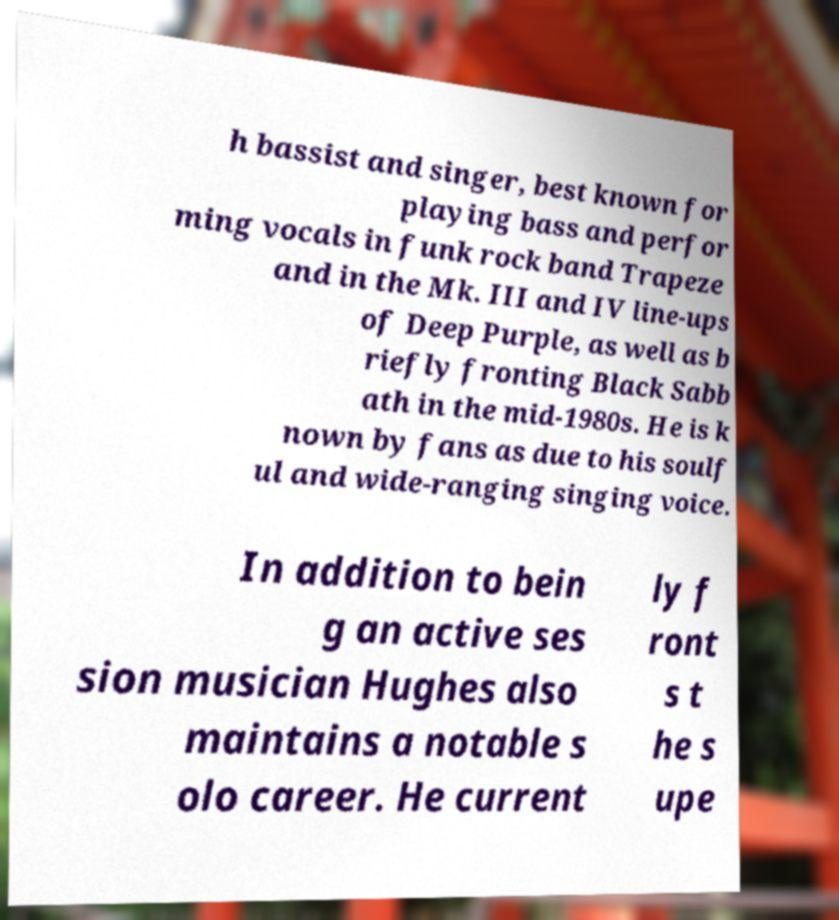Can you read and provide the text displayed in the image?This photo seems to have some interesting text. Can you extract and type it out for me? h bassist and singer, best known for playing bass and perfor ming vocals in funk rock band Trapeze and in the Mk. III and IV line-ups of Deep Purple, as well as b riefly fronting Black Sabb ath in the mid-1980s. He is k nown by fans as due to his soulf ul and wide-ranging singing voice. In addition to bein g an active ses sion musician Hughes also maintains a notable s olo career. He current ly f ront s t he s upe 